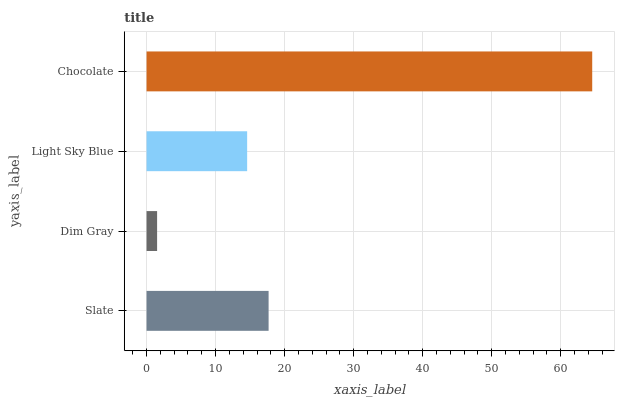Is Dim Gray the minimum?
Answer yes or no. Yes. Is Chocolate the maximum?
Answer yes or no. Yes. Is Light Sky Blue the minimum?
Answer yes or no. No. Is Light Sky Blue the maximum?
Answer yes or no. No. Is Light Sky Blue greater than Dim Gray?
Answer yes or no. Yes. Is Dim Gray less than Light Sky Blue?
Answer yes or no. Yes. Is Dim Gray greater than Light Sky Blue?
Answer yes or no. No. Is Light Sky Blue less than Dim Gray?
Answer yes or no. No. Is Slate the high median?
Answer yes or no. Yes. Is Light Sky Blue the low median?
Answer yes or no. Yes. Is Dim Gray the high median?
Answer yes or no. No. Is Chocolate the low median?
Answer yes or no. No. 